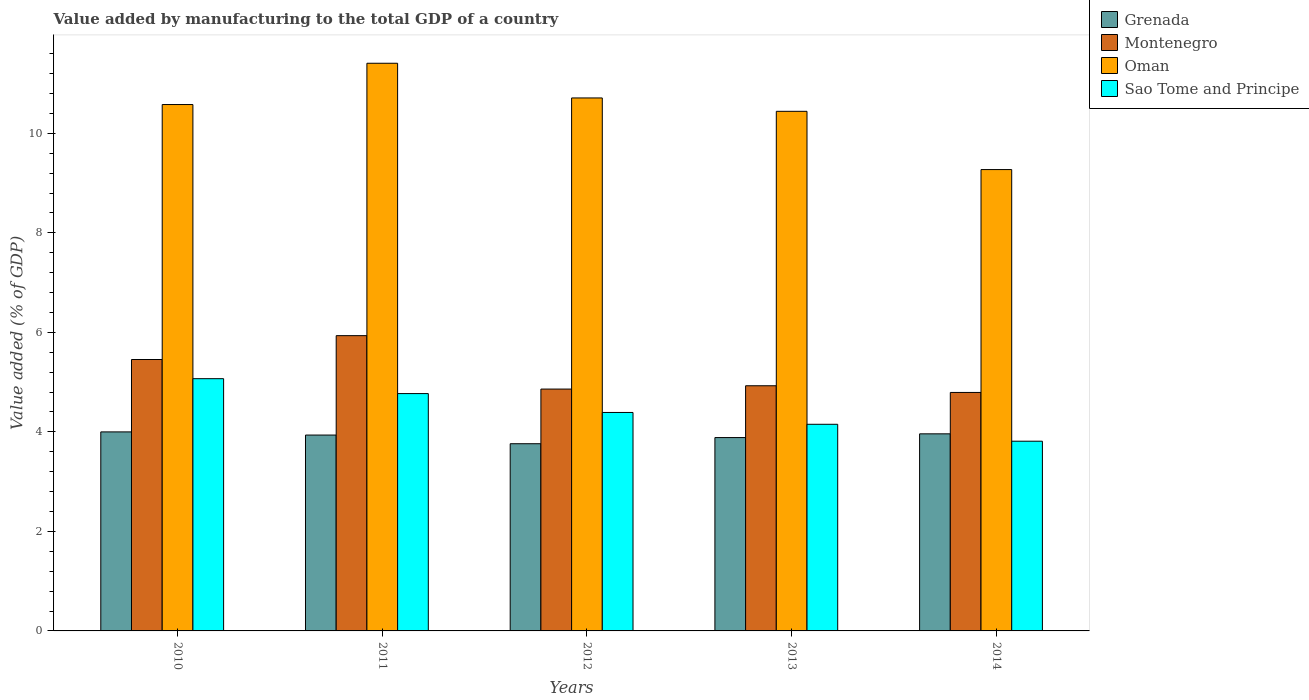How many groups of bars are there?
Keep it short and to the point. 5. Are the number of bars per tick equal to the number of legend labels?
Give a very brief answer. Yes. How many bars are there on the 5th tick from the left?
Your answer should be compact. 4. How many bars are there on the 2nd tick from the right?
Give a very brief answer. 4. What is the value added by manufacturing to the total GDP in Montenegro in 2012?
Offer a terse response. 4.86. Across all years, what is the maximum value added by manufacturing to the total GDP in Oman?
Provide a succinct answer. 11.41. Across all years, what is the minimum value added by manufacturing to the total GDP in Grenada?
Offer a terse response. 3.76. In which year was the value added by manufacturing to the total GDP in Montenegro maximum?
Your response must be concise. 2011. In which year was the value added by manufacturing to the total GDP in Montenegro minimum?
Your response must be concise. 2014. What is the total value added by manufacturing to the total GDP in Sao Tome and Principe in the graph?
Offer a terse response. 22.19. What is the difference between the value added by manufacturing to the total GDP in Oman in 2011 and that in 2013?
Your response must be concise. 0.97. What is the difference between the value added by manufacturing to the total GDP in Montenegro in 2014 and the value added by manufacturing to the total GDP in Grenada in 2013?
Your answer should be very brief. 0.91. What is the average value added by manufacturing to the total GDP in Montenegro per year?
Your answer should be very brief. 5.19. In the year 2010, what is the difference between the value added by manufacturing to the total GDP in Grenada and value added by manufacturing to the total GDP in Oman?
Your answer should be compact. -6.58. In how many years, is the value added by manufacturing to the total GDP in Montenegro greater than 1.2000000000000002 %?
Offer a terse response. 5. What is the ratio of the value added by manufacturing to the total GDP in Grenada in 2010 to that in 2013?
Ensure brevity in your answer.  1.03. Is the difference between the value added by manufacturing to the total GDP in Grenada in 2011 and 2012 greater than the difference between the value added by manufacturing to the total GDP in Oman in 2011 and 2012?
Ensure brevity in your answer.  No. What is the difference between the highest and the second highest value added by manufacturing to the total GDP in Montenegro?
Provide a succinct answer. 0.48. What is the difference between the highest and the lowest value added by manufacturing to the total GDP in Montenegro?
Offer a terse response. 1.14. In how many years, is the value added by manufacturing to the total GDP in Oman greater than the average value added by manufacturing to the total GDP in Oman taken over all years?
Provide a succinct answer. 3. Is the sum of the value added by manufacturing to the total GDP in Sao Tome and Principe in 2010 and 2012 greater than the maximum value added by manufacturing to the total GDP in Grenada across all years?
Ensure brevity in your answer.  Yes. What does the 4th bar from the left in 2011 represents?
Your answer should be very brief. Sao Tome and Principe. What does the 4th bar from the right in 2012 represents?
Your answer should be very brief. Grenada. How many years are there in the graph?
Your response must be concise. 5. Are the values on the major ticks of Y-axis written in scientific E-notation?
Your answer should be compact. No. Does the graph contain grids?
Keep it short and to the point. No. Where does the legend appear in the graph?
Your answer should be compact. Top right. What is the title of the graph?
Give a very brief answer. Value added by manufacturing to the total GDP of a country. What is the label or title of the X-axis?
Offer a terse response. Years. What is the label or title of the Y-axis?
Offer a terse response. Value added (% of GDP). What is the Value added (% of GDP) in Grenada in 2010?
Offer a very short reply. 4. What is the Value added (% of GDP) in Montenegro in 2010?
Your response must be concise. 5.45. What is the Value added (% of GDP) in Oman in 2010?
Your answer should be compact. 10.58. What is the Value added (% of GDP) of Sao Tome and Principe in 2010?
Offer a very short reply. 5.07. What is the Value added (% of GDP) in Grenada in 2011?
Make the answer very short. 3.94. What is the Value added (% of GDP) in Montenegro in 2011?
Keep it short and to the point. 5.93. What is the Value added (% of GDP) of Oman in 2011?
Your answer should be compact. 11.41. What is the Value added (% of GDP) of Sao Tome and Principe in 2011?
Give a very brief answer. 4.77. What is the Value added (% of GDP) of Grenada in 2012?
Your answer should be very brief. 3.76. What is the Value added (% of GDP) of Montenegro in 2012?
Provide a short and direct response. 4.86. What is the Value added (% of GDP) in Oman in 2012?
Keep it short and to the point. 10.71. What is the Value added (% of GDP) in Sao Tome and Principe in 2012?
Ensure brevity in your answer.  4.39. What is the Value added (% of GDP) of Grenada in 2013?
Your response must be concise. 3.89. What is the Value added (% of GDP) in Montenegro in 2013?
Give a very brief answer. 4.93. What is the Value added (% of GDP) of Oman in 2013?
Make the answer very short. 10.44. What is the Value added (% of GDP) of Sao Tome and Principe in 2013?
Provide a succinct answer. 4.15. What is the Value added (% of GDP) in Grenada in 2014?
Give a very brief answer. 3.96. What is the Value added (% of GDP) in Montenegro in 2014?
Your answer should be very brief. 4.79. What is the Value added (% of GDP) of Oman in 2014?
Your response must be concise. 9.27. What is the Value added (% of GDP) in Sao Tome and Principe in 2014?
Provide a succinct answer. 3.81. Across all years, what is the maximum Value added (% of GDP) in Grenada?
Offer a very short reply. 4. Across all years, what is the maximum Value added (% of GDP) of Montenegro?
Offer a very short reply. 5.93. Across all years, what is the maximum Value added (% of GDP) in Oman?
Ensure brevity in your answer.  11.41. Across all years, what is the maximum Value added (% of GDP) in Sao Tome and Principe?
Your answer should be compact. 5.07. Across all years, what is the minimum Value added (% of GDP) in Grenada?
Provide a succinct answer. 3.76. Across all years, what is the minimum Value added (% of GDP) of Montenegro?
Offer a very short reply. 4.79. Across all years, what is the minimum Value added (% of GDP) in Oman?
Give a very brief answer. 9.27. Across all years, what is the minimum Value added (% of GDP) of Sao Tome and Principe?
Make the answer very short. 3.81. What is the total Value added (% of GDP) in Grenada in the graph?
Keep it short and to the point. 19.54. What is the total Value added (% of GDP) in Montenegro in the graph?
Offer a terse response. 25.97. What is the total Value added (% of GDP) of Oman in the graph?
Offer a very short reply. 52.41. What is the total Value added (% of GDP) in Sao Tome and Principe in the graph?
Offer a very short reply. 22.19. What is the difference between the Value added (% of GDP) of Grenada in 2010 and that in 2011?
Offer a very short reply. 0.06. What is the difference between the Value added (% of GDP) in Montenegro in 2010 and that in 2011?
Your answer should be very brief. -0.48. What is the difference between the Value added (% of GDP) of Oman in 2010 and that in 2011?
Offer a very short reply. -0.83. What is the difference between the Value added (% of GDP) in Sao Tome and Principe in 2010 and that in 2011?
Offer a terse response. 0.3. What is the difference between the Value added (% of GDP) in Grenada in 2010 and that in 2012?
Your response must be concise. 0.24. What is the difference between the Value added (% of GDP) in Montenegro in 2010 and that in 2012?
Offer a very short reply. 0.59. What is the difference between the Value added (% of GDP) of Oman in 2010 and that in 2012?
Offer a very short reply. -0.13. What is the difference between the Value added (% of GDP) of Sao Tome and Principe in 2010 and that in 2012?
Make the answer very short. 0.68. What is the difference between the Value added (% of GDP) in Grenada in 2010 and that in 2013?
Give a very brief answer. 0.11. What is the difference between the Value added (% of GDP) of Montenegro in 2010 and that in 2013?
Keep it short and to the point. 0.53. What is the difference between the Value added (% of GDP) of Oman in 2010 and that in 2013?
Make the answer very short. 0.14. What is the difference between the Value added (% of GDP) in Sao Tome and Principe in 2010 and that in 2013?
Your answer should be compact. 0.92. What is the difference between the Value added (% of GDP) in Grenada in 2010 and that in 2014?
Provide a succinct answer. 0.04. What is the difference between the Value added (% of GDP) of Montenegro in 2010 and that in 2014?
Provide a short and direct response. 0.66. What is the difference between the Value added (% of GDP) in Oman in 2010 and that in 2014?
Offer a very short reply. 1.31. What is the difference between the Value added (% of GDP) in Sao Tome and Principe in 2010 and that in 2014?
Your response must be concise. 1.26. What is the difference between the Value added (% of GDP) of Grenada in 2011 and that in 2012?
Provide a succinct answer. 0.17. What is the difference between the Value added (% of GDP) in Montenegro in 2011 and that in 2012?
Provide a succinct answer. 1.07. What is the difference between the Value added (% of GDP) of Oman in 2011 and that in 2012?
Offer a very short reply. 0.7. What is the difference between the Value added (% of GDP) of Sao Tome and Principe in 2011 and that in 2012?
Your response must be concise. 0.38. What is the difference between the Value added (% of GDP) in Grenada in 2011 and that in 2013?
Ensure brevity in your answer.  0.05. What is the difference between the Value added (% of GDP) of Montenegro in 2011 and that in 2013?
Your response must be concise. 1.01. What is the difference between the Value added (% of GDP) in Oman in 2011 and that in 2013?
Give a very brief answer. 0.97. What is the difference between the Value added (% of GDP) of Sao Tome and Principe in 2011 and that in 2013?
Offer a terse response. 0.62. What is the difference between the Value added (% of GDP) in Grenada in 2011 and that in 2014?
Keep it short and to the point. -0.02. What is the difference between the Value added (% of GDP) in Montenegro in 2011 and that in 2014?
Provide a succinct answer. 1.14. What is the difference between the Value added (% of GDP) in Oman in 2011 and that in 2014?
Provide a succinct answer. 2.14. What is the difference between the Value added (% of GDP) of Sao Tome and Principe in 2011 and that in 2014?
Make the answer very short. 0.96. What is the difference between the Value added (% of GDP) of Grenada in 2012 and that in 2013?
Your response must be concise. -0.12. What is the difference between the Value added (% of GDP) in Montenegro in 2012 and that in 2013?
Your answer should be compact. -0.07. What is the difference between the Value added (% of GDP) in Oman in 2012 and that in 2013?
Give a very brief answer. 0.27. What is the difference between the Value added (% of GDP) in Sao Tome and Principe in 2012 and that in 2013?
Make the answer very short. 0.24. What is the difference between the Value added (% of GDP) of Grenada in 2012 and that in 2014?
Keep it short and to the point. -0.2. What is the difference between the Value added (% of GDP) in Montenegro in 2012 and that in 2014?
Keep it short and to the point. 0.07. What is the difference between the Value added (% of GDP) in Oman in 2012 and that in 2014?
Keep it short and to the point. 1.44. What is the difference between the Value added (% of GDP) in Sao Tome and Principe in 2012 and that in 2014?
Provide a succinct answer. 0.58. What is the difference between the Value added (% of GDP) of Grenada in 2013 and that in 2014?
Provide a short and direct response. -0.08. What is the difference between the Value added (% of GDP) of Montenegro in 2013 and that in 2014?
Keep it short and to the point. 0.13. What is the difference between the Value added (% of GDP) in Oman in 2013 and that in 2014?
Provide a succinct answer. 1.17. What is the difference between the Value added (% of GDP) of Sao Tome and Principe in 2013 and that in 2014?
Ensure brevity in your answer.  0.34. What is the difference between the Value added (% of GDP) in Grenada in 2010 and the Value added (% of GDP) in Montenegro in 2011?
Provide a succinct answer. -1.93. What is the difference between the Value added (% of GDP) in Grenada in 2010 and the Value added (% of GDP) in Oman in 2011?
Your answer should be very brief. -7.41. What is the difference between the Value added (% of GDP) of Grenada in 2010 and the Value added (% of GDP) of Sao Tome and Principe in 2011?
Offer a very short reply. -0.77. What is the difference between the Value added (% of GDP) in Montenegro in 2010 and the Value added (% of GDP) in Oman in 2011?
Ensure brevity in your answer.  -5.95. What is the difference between the Value added (% of GDP) in Montenegro in 2010 and the Value added (% of GDP) in Sao Tome and Principe in 2011?
Your response must be concise. 0.69. What is the difference between the Value added (% of GDP) in Oman in 2010 and the Value added (% of GDP) in Sao Tome and Principe in 2011?
Provide a short and direct response. 5.81. What is the difference between the Value added (% of GDP) in Grenada in 2010 and the Value added (% of GDP) in Montenegro in 2012?
Provide a short and direct response. -0.86. What is the difference between the Value added (% of GDP) in Grenada in 2010 and the Value added (% of GDP) in Oman in 2012?
Your response must be concise. -6.71. What is the difference between the Value added (% of GDP) in Grenada in 2010 and the Value added (% of GDP) in Sao Tome and Principe in 2012?
Your response must be concise. -0.39. What is the difference between the Value added (% of GDP) in Montenegro in 2010 and the Value added (% of GDP) in Oman in 2012?
Ensure brevity in your answer.  -5.26. What is the difference between the Value added (% of GDP) of Montenegro in 2010 and the Value added (% of GDP) of Sao Tome and Principe in 2012?
Provide a short and direct response. 1.06. What is the difference between the Value added (% of GDP) of Oman in 2010 and the Value added (% of GDP) of Sao Tome and Principe in 2012?
Ensure brevity in your answer.  6.19. What is the difference between the Value added (% of GDP) in Grenada in 2010 and the Value added (% of GDP) in Montenegro in 2013?
Your response must be concise. -0.93. What is the difference between the Value added (% of GDP) of Grenada in 2010 and the Value added (% of GDP) of Oman in 2013?
Your answer should be very brief. -6.44. What is the difference between the Value added (% of GDP) of Grenada in 2010 and the Value added (% of GDP) of Sao Tome and Principe in 2013?
Ensure brevity in your answer.  -0.15. What is the difference between the Value added (% of GDP) in Montenegro in 2010 and the Value added (% of GDP) in Oman in 2013?
Offer a terse response. -4.99. What is the difference between the Value added (% of GDP) of Montenegro in 2010 and the Value added (% of GDP) of Sao Tome and Principe in 2013?
Your response must be concise. 1.3. What is the difference between the Value added (% of GDP) in Oman in 2010 and the Value added (% of GDP) in Sao Tome and Principe in 2013?
Provide a succinct answer. 6.43. What is the difference between the Value added (% of GDP) of Grenada in 2010 and the Value added (% of GDP) of Montenegro in 2014?
Your answer should be very brief. -0.79. What is the difference between the Value added (% of GDP) in Grenada in 2010 and the Value added (% of GDP) in Oman in 2014?
Keep it short and to the point. -5.27. What is the difference between the Value added (% of GDP) in Grenada in 2010 and the Value added (% of GDP) in Sao Tome and Principe in 2014?
Make the answer very short. 0.19. What is the difference between the Value added (% of GDP) in Montenegro in 2010 and the Value added (% of GDP) in Oman in 2014?
Your response must be concise. -3.82. What is the difference between the Value added (% of GDP) of Montenegro in 2010 and the Value added (% of GDP) of Sao Tome and Principe in 2014?
Your answer should be very brief. 1.64. What is the difference between the Value added (% of GDP) in Oman in 2010 and the Value added (% of GDP) in Sao Tome and Principe in 2014?
Your response must be concise. 6.77. What is the difference between the Value added (% of GDP) in Grenada in 2011 and the Value added (% of GDP) in Montenegro in 2012?
Provide a succinct answer. -0.92. What is the difference between the Value added (% of GDP) in Grenada in 2011 and the Value added (% of GDP) in Oman in 2012?
Make the answer very short. -6.77. What is the difference between the Value added (% of GDP) of Grenada in 2011 and the Value added (% of GDP) of Sao Tome and Principe in 2012?
Provide a succinct answer. -0.45. What is the difference between the Value added (% of GDP) of Montenegro in 2011 and the Value added (% of GDP) of Oman in 2012?
Provide a succinct answer. -4.78. What is the difference between the Value added (% of GDP) of Montenegro in 2011 and the Value added (% of GDP) of Sao Tome and Principe in 2012?
Offer a very short reply. 1.54. What is the difference between the Value added (% of GDP) of Oman in 2011 and the Value added (% of GDP) of Sao Tome and Principe in 2012?
Provide a short and direct response. 7.02. What is the difference between the Value added (% of GDP) of Grenada in 2011 and the Value added (% of GDP) of Montenegro in 2013?
Make the answer very short. -0.99. What is the difference between the Value added (% of GDP) of Grenada in 2011 and the Value added (% of GDP) of Oman in 2013?
Give a very brief answer. -6.51. What is the difference between the Value added (% of GDP) of Grenada in 2011 and the Value added (% of GDP) of Sao Tome and Principe in 2013?
Your answer should be compact. -0.22. What is the difference between the Value added (% of GDP) of Montenegro in 2011 and the Value added (% of GDP) of Oman in 2013?
Make the answer very short. -4.51. What is the difference between the Value added (% of GDP) in Montenegro in 2011 and the Value added (% of GDP) in Sao Tome and Principe in 2013?
Keep it short and to the point. 1.78. What is the difference between the Value added (% of GDP) in Oman in 2011 and the Value added (% of GDP) in Sao Tome and Principe in 2013?
Your answer should be compact. 7.26. What is the difference between the Value added (% of GDP) of Grenada in 2011 and the Value added (% of GDP) of Montenegro in 2014?
Offer a terse response. -0.86. What is the difference between the Value added (% of GDP) in Grenada in 2011 and the Value added (% of GDP) in Oman in 2014?
Ensure brevity in your answer.  -5.34. What is the difference between the Value added (% of GDP) in Grenada in 2011 and the Value added (% of GDP) in Sao Tome and Principe in 2014?
Your answer should be compact. 0.12. What is the difference between the Value added (% of GDP) of Montenegro in 2011 and the Value added (% of GDP) of Oman in 2014?
Your answer should be compact. -3.34. What is the difference between the Value added (% of GDP) of Montenegro in 2011 and the Value added (% of GDP) of Sao Tome and Principe in 2014?
Your response must be concise. 2.12. What is the difference between the Value added (% of GDP) in Oman in 2011 and the Value added (% of GDP) in Sao Tome and Principe in 2014?
Offer a very short reply. 7.6. What is the difference between the Value added (% of GDP) in Grenada in 2012 and the Value added (% of GDP) in Montenegro in 2013?
Offer a terse response. -1.17. What is the difference between the Value added (% of GDP) of Grenada in 2012 and the Value added (% of GDP) of Oman in 2013?
Your response must be concise. -6.68. What is the difference between the Value added (% of GDP) in Grenada in 2012 and the Value added (% of GDP) in Sao Tome and Principe in 2013?
Keep it short and to the point. -0.39. What is the difference between the Value added (% of GDP) in Montenegro in 2012 and the Value added (% of GDP) in Oman in 2013?
Offer a terse response. -5.58. What is the difference between the Value added (% of GDP) in Montenegro in 2012 and the Value added (% of GDP) in Sao Tome and Principe in 2013?
Ensure brevity in your answer.  0.71. What is the difference between the Value added (% of GDP) of Oman in 2012 and the Value added (% of GDP) of Sao Tome and Principe in 2013?
Provide a short and direct response. 6.56. What is the difference between the Value added (% of GDP) of Grenada in 2012 and the Value added (% of GDP) of Montenegro in 2014?
Offer a very short reply. -1.03. What is the difference between the Value added (% of GDP) in Grenada in 2012 and the Value added (% of GDP) in Oman in 2014?
Ensure brevity in your answer.  -5.51. What is the difference between the Value added (% of GDP) in Grenada in 2012 and the Value added (% of GDP) in Sao Tome and Principe in 2014?
Your answer should be compact. -0.05. What is the difference between the Value added (% of GDP) of Montenegro in 2012 and the Value added (% of GDP) of Oman in 2014?
Your answer should be compact. -4.41. What is the difference between the Value added (% of GDP) of Montenegro in 2012 and the Value added (% of GDP) of Sao Tome and Principe in 2014?
Keep it short and to the point. 1.05. What is the difference between the Value added (% of GDP) in Oman in 2012 and the Value added (% of GDP) in Sao Tome and Principe in 2014?
Ensure brevity in your answer.  6.9. What is the difference between the Value added (% of GDP) of Grenada in 2013 and the Value added (% of GDP) of Montenegro in 2014?
Your answer should be very brief. -0.91. What is the difference between the Value added (% of GDP) of Grenada in 2013 and the Value added (% of GDP) of Oman in 2014?
Provide a short and direct response. -5.39. What is the difference between the Value added (% of GDP) of Grenada in 2013 and the Value added (% of GDP) of Sao Tome and Principe in 2014?
Provide a short and direct response. 0.07. What is the difference between the Value added (% of GDP) of Montenegro in 2013 and the Value added (% of GDP) of Oman in 2014?
Offer a very short reply. -4.34. What is the difference between the Value added (% of GDP) of Montenegro in 2013 and the Value added (% of GDP) of Sao Tome and Principe in 2014?
Offer a terse response. 1.11. What is the difference between the Value added (% of GDP) in Oman in 2013 and the Value added (% of GDP) in Sao Tome and Principe in 2014?
Ensure brevity in your answer.  6.63. What is the average Value added (% of GDP) of Grenada per year?
Ensure brevity in your answer.  3.91. What is the average Value added (% of GDP) in Montenegro per year?
Make the answer very short. 5.19. What is the average Value added (% of GDP) of Oman per year?
Your response must be concise. 10.48. What is the average Value added (% of GDP) in Sao Tome and Principe per year?
Keep it short and to the point. 4.44. In the year 2010, what is the difference between the Value added (% of GDP) of Grenada and Value added (% of GDP) of Montenegro?
Offer a terse response. -1.45. In the year 2010, what is the difference between the Value added (% of GDP) of Grenada and Value added (% of GDP) of Oman?
Offer a terse response. -6.58. In the year 2010, what is the difference between the Value added (% of GDP) of Grenada and Value added (% of GDP) of Sao Tome and Principe?
Offer a terse response. -1.07. In the year 2010, what is the difference between the Value added (% of GDP) of Montenegro and Value added (% of GDP) of Oman?
Offer a terse response. -5.12. In the year 2010, what is the difference between the Value added (% of GDP) in Montenegro and Value added (% of GDP) in Sao Tome and Principe?
Offer a very short reply. 0.39. In the year 2010, what is the difference between the Value added (% of GDP) in Oman and Value added (% of GDP) in Sao Tome and Principe?
Give a very brief answer. 5.51. In the year 2011, what is the difference between the Value added (% of GDP) of Grenada and Value added (% of GDP) of Montenegro?
Your answer should be very brief. -2. In the year 2011, what is the difference between the Value added (% of GDP) of Grenada and Value added (% of GDP) of Oman?
Your answer should be very brief. -7.47. In the year 2011, what is the difference between the Value added (% of GDP) of Grenada and Value added (% of GDP) of Sao Tome and Principe?
Ensure brevity in your answer.  -0.83. In the year 2011, what is the difference between the Value added (% of GDP) of Montenegro and Value added (% of GDP) of Oman?
Ensure brevity in your answer.  -5.47. In the year 2011, what is the difference between the Value added (% of GDP) in Montenegro and Value added (% of GDP) in Sao Tome and Principe?
Make the answer very short. 1.16. In the year 2011, what is the difference between the Value added (% of GDP) of Oman and Value added (% of GDP) of Sao Tome and Principe?
Your answer should be compact. 6.64. In the year 2012, what is the difference between the Value added (% of GDP) in Grenada and Value added (% of GDP) in Montenegro?
Your answer should be very brief. -1.1. In the year 2012, what is the difference between the Value added (% of GDP) of Grenada and Value added (% of GDP) of Oman?
Ensure brevity in your answer.  -6.95. In the year 2012, what is the difference between the Value added (% of GDP) of Grenada and Value added (% of GDP) of Sao Tome and Principe?
Your answer should be compact. -0.63. In the year 2012, what is the difference between the Value added (% of GDP) in Montenegro and Value added (% of GDP) in Oman?
Offer a very short reply. -5.85. In the year 2012, what is the difference between the Value added (% of GDP) of Montenegro and Value added (% of GDP) of Sao Tome and Principe?
Your response must be concise. 0.47. In the year 2012, what is the difference between the Value added (% of GDP) of Oman and Value added (% of GDP) of Sao Tome and Principe?
Keep it short and to the point. 6.32. In the year 2013, what is the difference between the Value added (% of GDP) in Grenada and Value added (% of GDP) in Montenegro?
Keep it short and to the point. -1.04. In the year 2013, what is the difference between the Value added (% of GDP) of Grenada and Value added (% of GDP) of Oman?
Your answer should be compact. -6.56. In the year 2013, what is the difference between the Value added (% of GDP) of Grenada and Value added (% of GDP) of Sao Tome and Principe?
Keep it short and to the point. -0.27. In the year 2013, what is the difference between the Value added (% of GDP) in Montenegro and Value added (% of GDP) in Oman?
Keep it short and to the point. -5.51. In the year 2013, what is the difference between the Value added (% of GDP) of Montenegro and Value added (% of GDP) of Sao Tome and Principe?
Offer a terse response. 0.77. In the year 2013, what is the difference between the Value added (% of GDP) of Oman and Value added (% of GDP) of Sao Tome and Principe?
Make the answer very short. 6.29. In the year 2014, what is the difference between the Value added (% of GDP) in Grenada and Value added (% of GDP) in Montenegro?
Offer a terse response. -0.83. In the year 2014, what is the difference between the Value added (% of GDP) in Grenada and Value added (% of GDP) in Oman?
Your response must be concise. -5.31. In the year 2014, what is the difference between the Value added (% of GDP) in Grenada and Value added (% of GDP) in Sao Tome and Principe?
Ensure brevity in your answer.  0.15. In the year 2014, what is the difference between the Value added (% of GDP) in Montenegro and Value added (% of GDP) in Oman?
Give a very brief answer. -4.48. In the year 2014, what is the difference between the Value added (% of GDP) in Montenegro and Value added (% of GDP) in Sao Tome and Principe?
Provide a succinct answer. 0.98. In the year 2014, what is the difference between the Value added (% of GDP) of Oman and Value added (% of GDP) of Sao Tome and Principe?
Your response must be concise. 5.46. What is the ratio of the Value added (% of GDP) in Grenada in 2010 to that in 2011?
Offer a terse response. 1.02. What is the ratio of the Value added (% of GDP) of Montenegro in 2010 to that in 2011?
Ensure brevity in your answer.  0.92. What is the ratio of the Value added (% of GDP) in Oman in 2010 to that in 2011?
Your answer should be very brief. 0.93. What is the ratio of the Value added (% of GDP) of Sao Tome and Principe in 2010 to that in 2011?
Make the answer very short. 1.06. What is the ratio of the Value added (% of GDP) in Grenada in 2010 to that in 2012?
Provide a succinct answer. 1.06. What is the ratio of the Value added (% of GDP) of Montenegro in 2010 to that in 2012?
Your response must be concise. 1.12. What is the ratio of the Value added (% of GDP) in Oman in 2010 to that in 2012?
Give a very brief answer. 0.99. What is the ratio of the Value added (% of GDP) of Sao Tome and Principe in 2010 to that in 2012?
Keep it short and to the point. 1.15. What is the ratio of the Value added (% of GDP) in Grenada in 2010 to that in 2013?
Offer a terse response. 1.03. What is the ratio of the Value added (% of GDP) in Montenegro in 2010 to that in 2013?
Provide a succinct answer. 1.11. What is the ratio of the Value added (% of GDP) in Oman in 2010 to that in 2013?
Give a very brief answer. 1.01. What is the ratio of the Value added (% of GDP) in Sao Tome and Principe in 2010 to that in 2013?
Offer a terse response. 1.22. What is the ratio of the Value added (% of GDP) of Grenada in 2010 to that in 2014?
Provide a short and direct response. 1.01. What is the ratio of the Value added (% of GDP) in Montenegro in 2010 to that in 2014?
Make the answer very short. 1.14. What is the ratio of the Value added (% of GDP) of Oman in 2010 to that in 2014?
Your response must be concise. 1.14. What is the ratio of the Value added (% of GDP) in Sao Tome and Principe in 2010 to that in 2014?
Provide a short and direct response. 1.33. What is the ratio of the Value added (% of GDP) in Grenada in 2011 to that in 2012?
Provide a succinct answer. 1.05. What is the ratio of the Value added (% of GDP) in Montenegro in 2011 to that in 2012?
Keep it short and to the point. 1.22. What is the ratio of the Value added (% of GDP) of Oman in 2011 to that in 2012?
Your answer should be very brief. 1.07. What is the ratio of the Value added (% of GDP) in Sao Tome and Principe in 2011 to that in 2012?
Offer a terse response. 1.09. What is the ratio of the Value added (% of GDP) of Montenegro in 2011 to that in 2013?
Provide a succinct answer. 1.2. What is the ratio of the Value added (% of GDP) of Oman in 2011 to that in 2013?
Your response must be concise. 1.09. What is the ratio of the Value added (% of GDP) of Sao Tome and Principe in 2011 to that in 2013?
Your answer should be compact. 1.15. What is the ratio of the Value added (% of GDP) of Montenegro in 2011 to that in 2014?
Keep it short and to the point. 1.24. What is the ratio of the Value added (% of GDP) in Oman in 2011 to that in 2014?
Offer a very short reply. 1.23. What is the ratio of the Value added (% of GDP) in Sao Tome and Principe in 2011 to that in 2014?
Offer a very short reply. 1.25. What is the ratio of the Value added (% of GDP) in Grenada in 2012 to that in 2013?
Make the answer very short. 0.97. What is the ratio of the Value added (% of GDP) in Montenegro in 2012 to that in 2013?
Give a very brief answer. 0.99. What is the ratio of the Value added (% of GDP) in Oman in 2012 to that in 2013?
Your response must be concise. 1.03. What is the ratio of the Value added (% of GDP) in Sao Tome and Principe in 2012 to that in 2013?
Provide a succinct answer. 1.06. What is the ratio of the Value added (% of GDP) in Grenada in 2012 to that in 2014?
Offer a very short reply. 0.95. What is the ratio of the Value added (% of GDP) of Montenegro in 2012 to that in 2014?
Keep it short and to the point. 1.01. What is the ratio of the Value added (% of GDP) of Oman in 2012 to that in 2014?
Keep it short and to the point. 1.16. What is the ratio of the Value added (% of GDP) in Sao Tome and Principe in 2012 to that in 2014?
Your answer should be compact. 1.15. What is the ratio of the Value added (% of GDP) in Montenegro in 2013 to that in 2014?
Your answer should be compact. 1.03. What is the ratio of the Value added (% of GDP) in Oman in 2013 to that in 2014?
Your response must be concise. 1.13. What is the ratio of the Value added (% of GDP) in Sao Tome and Principe in 2013 to that in 2014?
Offer a very short reply. 1.09. What is the difference between the highest and the second highest Value added (% of GDP) of Grenada?
Your response must be concise. 0.04. What is the difference between the highest and the second highest Value added (% of GDP) of Montenegro?
Make the answer very short. 0.48. What is the difference between the highest and the second highest Value added (% of GDP) in Oman?
Give a very brief answer. 0.7. What is the difference between the highest and the second highest Value added (% of GDP) of Sao Tome and Principe?
Make the answer very short. 0.3. What is the difference between the highest and the lowest Value added (% of GDP) in Grenada?
Make the answer very short. 0.24. What is the difference between the highest and the lowest Value added (% of GDP) of Montenegro?
Your answer should be compact. 1.14. What is the difference between the highest and the lowest Value added (% of GDP) of Oman?
Ensure brevity in your answer.  2.14. What is the difference between the highest and the lowest Value added (% of GDP) of Sao Tome and Principe?
Offer a terse response. 1.26. 